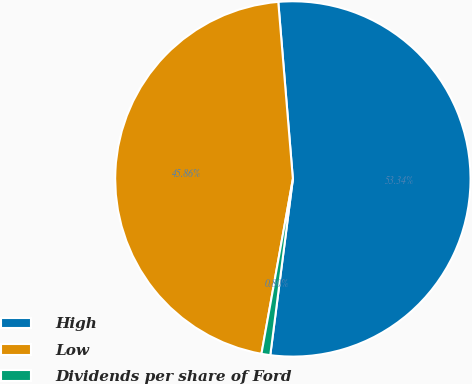Convert chart. <chart><loc_0><loc_0><loc_500><loc_500><pie_chart><fcel>High<fcel>Low<fcel>Dividends per share of Ford<nl><fcel>53.34%<fcel>45.86%<fcel>0.8%<nl></chart> 